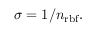<formula> <loc_0><loc_0><loc_500><loc_500>\sigma = 1 / n _ { r b f } .</formula> 